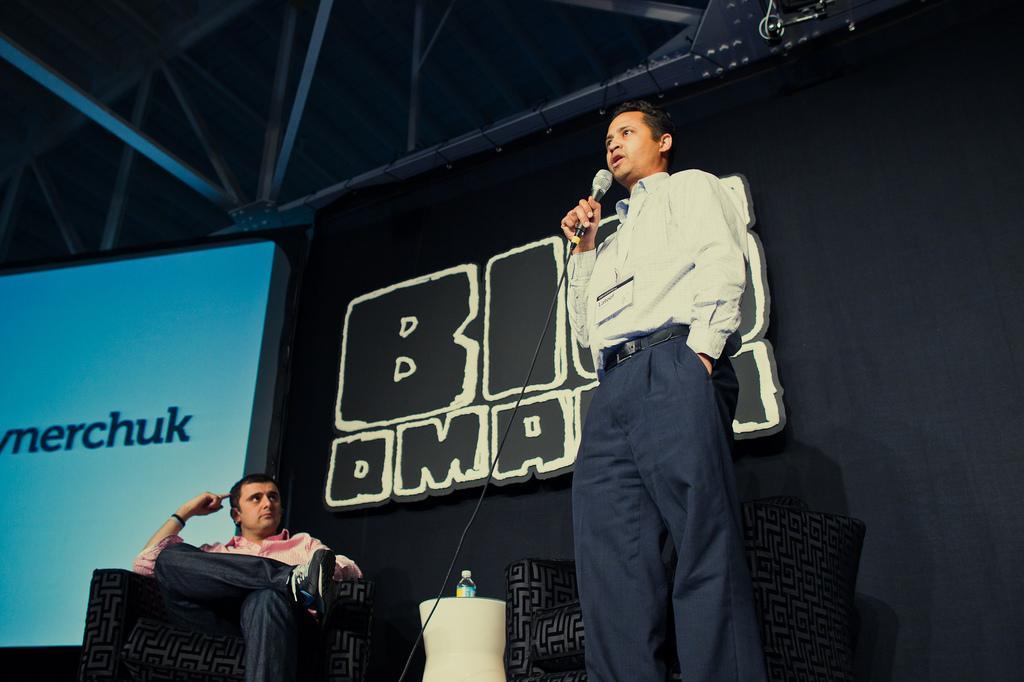In one or two sentences, can you explain what this image depicts? There is a man standing and holding a microphone and this man sitting on a chair and we can see chairs. In the background we can see screen,board and rods. 